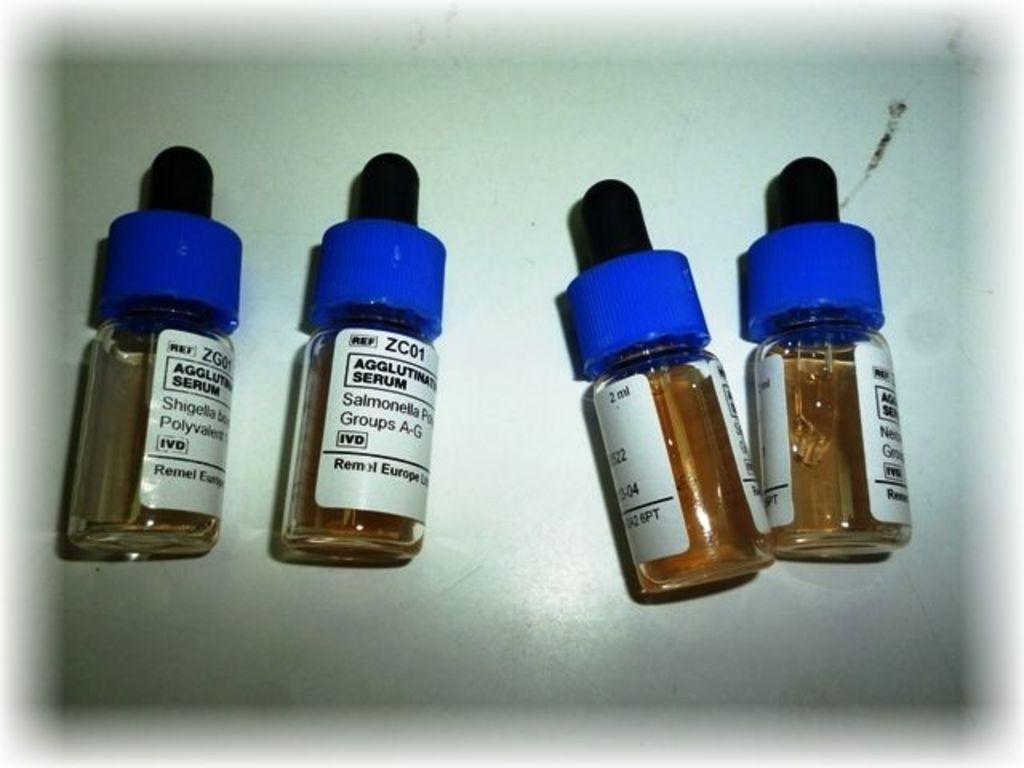<image>
Share a concise interpretation of the image provided. four glass bottles of aqqlut serum laying on their sides 